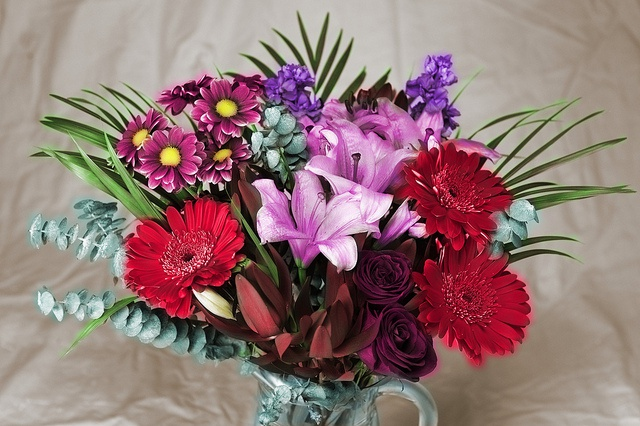Describe the objects in this image and their specific colors. I can see potted plant in gray, darkgray, black, maroon, and brown tones and vase in gray and darkgray tones in this image. 